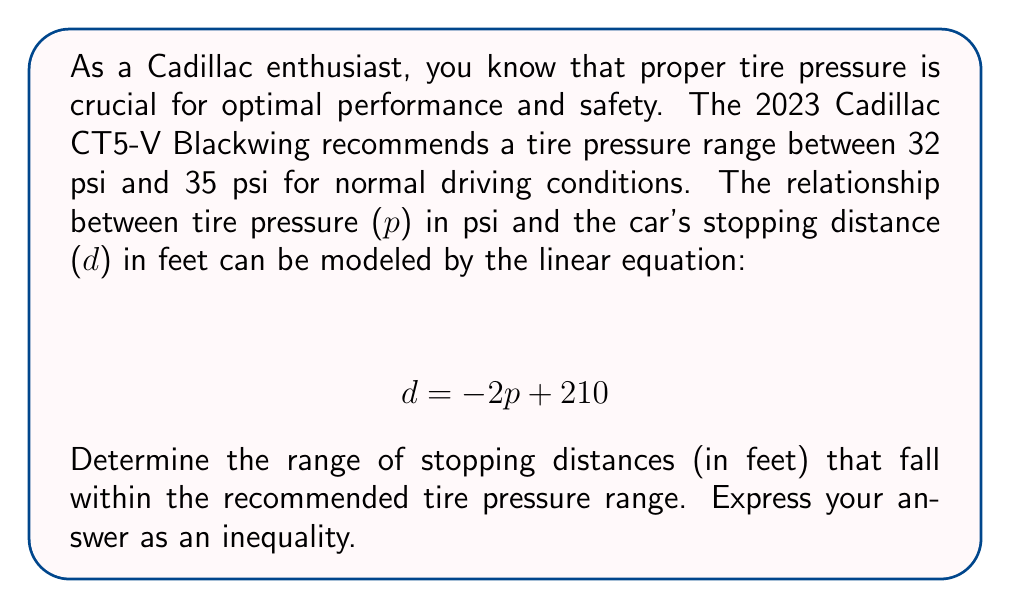Help me with this question. To solve this problem, we'll follow these steps:

1. Identify the given information:
   - Recommended tire pressure range: 32 psi to 35 psi
   - Linear equation: $d = -2p + 210$

2. Find the stopping distance for the lower tire pressure limit (32 psi):
   $d_{lower} = -2(32) + 210 = -64 + 210 = 146$ feet

3. Find the stopping distance for the upper tire pressure limit (35 psi):
   $d_{upper} = -2(35) + 210 = -70 + 210 = 140$ feet

4. Set up the inequality:
   Since the stopping distance decreases as tire pressure increases, we know that the longer stopping distance (146 feet) corresponds to the lower pressure limit, and the shorter stopping distance (140 feet) corresponds to the upper pressure limit.

   Therefore, the range of stopping distances can be expressed as:
   $$ 140 \leq d \leq 146 $$

This inequality represents all stopping distances that fall within the recommended tire pressure range for the 2023 Cadillac CT5-V Blackwing.
Answer: $$ 140 \leq d \leq 146 $$ 